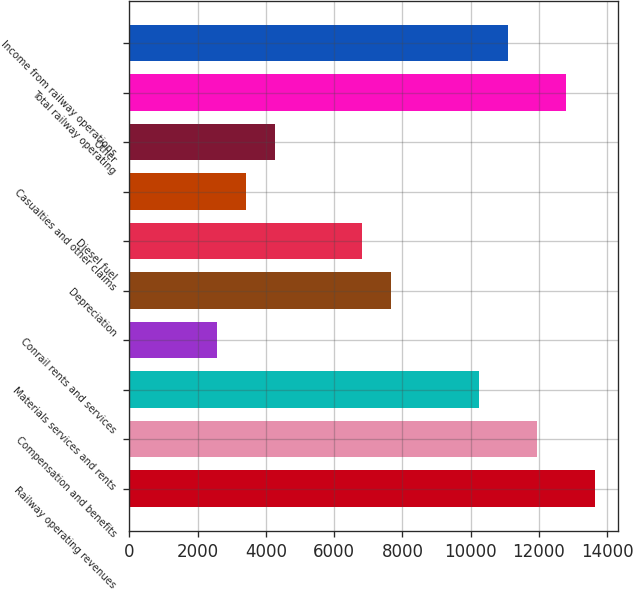<chart> <loc_0><loc_0><loc_500><loc_500><bar_chart><fcel>Railway operating revenues<fcel>Compensation and benefits<fcel>Materials services and rents<fcel>Conrail rents and services<fcel>Depreciation<fcel>Diesel fuel<fcel>Casualties and other claims<fcel>Other<fcel>Total railway operating<fcel>Income from railway operations<nl><fcel>13641.4<fcel>11936.6<fcel>10231.8<fcel>2560.28<fcel>7674.62<fcel>6822.23<fcel>3412.67<fcel>4265.06<fcel>12789<fcel>11084.2<nl></chart> 